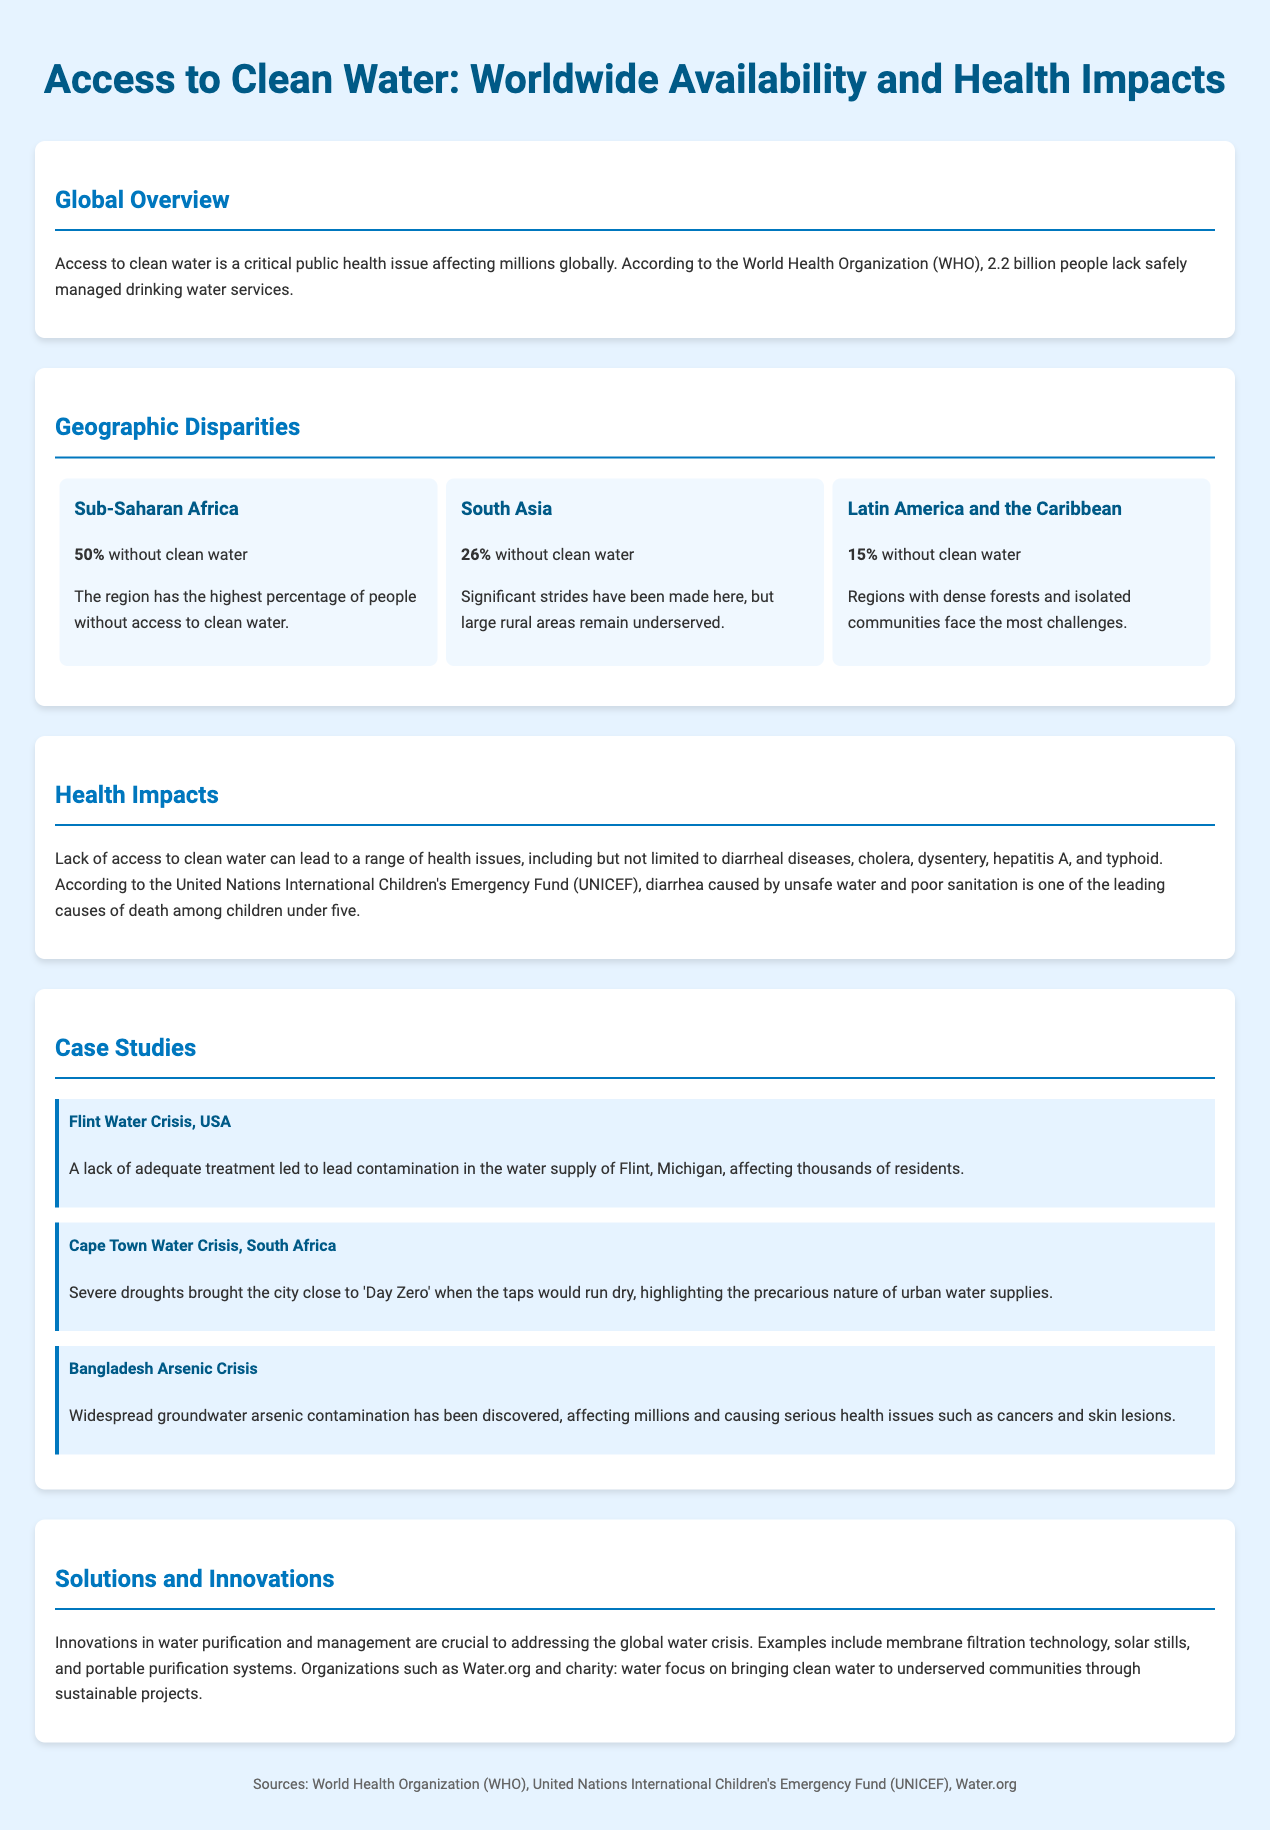What percentage of Sub-Saharan Africa lacks clean water? The document states that Sub-Saharan Africa has a percentage of people without access to clean water, which is 50%.
Answer: 50% What organization reports that 2.2 billion people lack safely managed drinking water services? The document mentions that this statistic comes from the World Health Organization (WHO).
Answer: World Health Organization (WHO) What health issue is one of the leading causes of death among children under five? The document highlights diarrhea caused by unsafe water and poor sanitation as a leading cause of death in this age group.
Answer: Diarrhea What is the percentage of people without clean water in Latin America and the Caribbean? The document states that 15% of people in Latin America and the Caribbean lack access to clean water.
Answer: 15% What crisis affected the water supply of Flint, Michigan? The document refers to the Flint Water Crisis as the situation that led to lead contamination in the water supply.
Answer: Flint Water Crisis Which technology is mentioned as a solution for addressing the global water crisis? The document lists membrane filtration technology as an example of innovation in water purification and management.
Answer: Membrane filtration technology How many people lacks safely managed drinking water services worldwide? The document cites that 2.2 billion people are affected worldwide according to the WHO.
Answer: 2.2 billion What tragic health effect does arsenic contamination cause in Bangladesh? The document mentions serious health issues including cancers and skin lesions due to arsenic contamination.
Answer: Cancers and skin lesions 